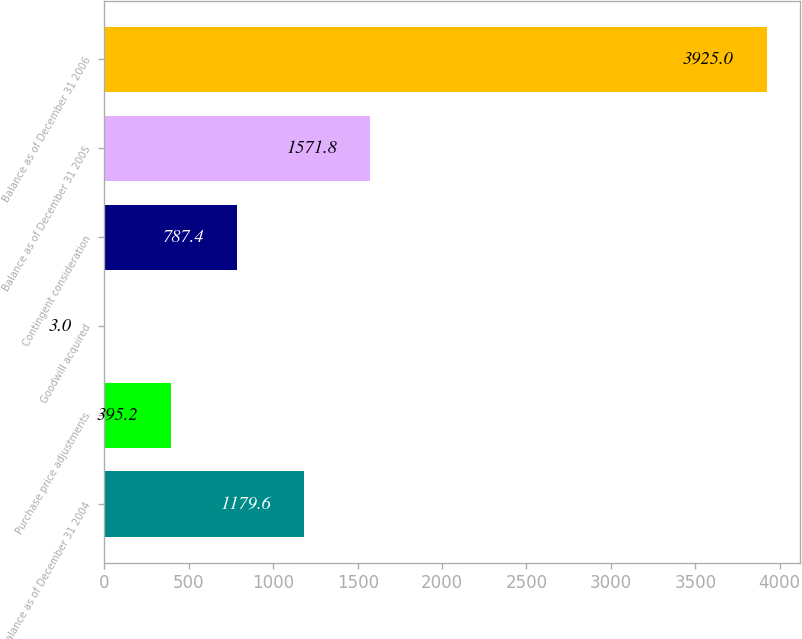<chart> <loc_0><loc_0><loc_500><loc_500><bar_chart><fcel>Balance as of December 31 2004<fcel>Purchase price adjustments<fcel>Goodwill acquired<fcel>Contingent consideration<fcel>Balance as of December 31 2005<fcel>Balance as of December 31 2006<nl><fcel>1179.6<fcel>395.2<fcel>3<fcel>787.4<fcel>1571.8<fcel>3925<nl></chart> 